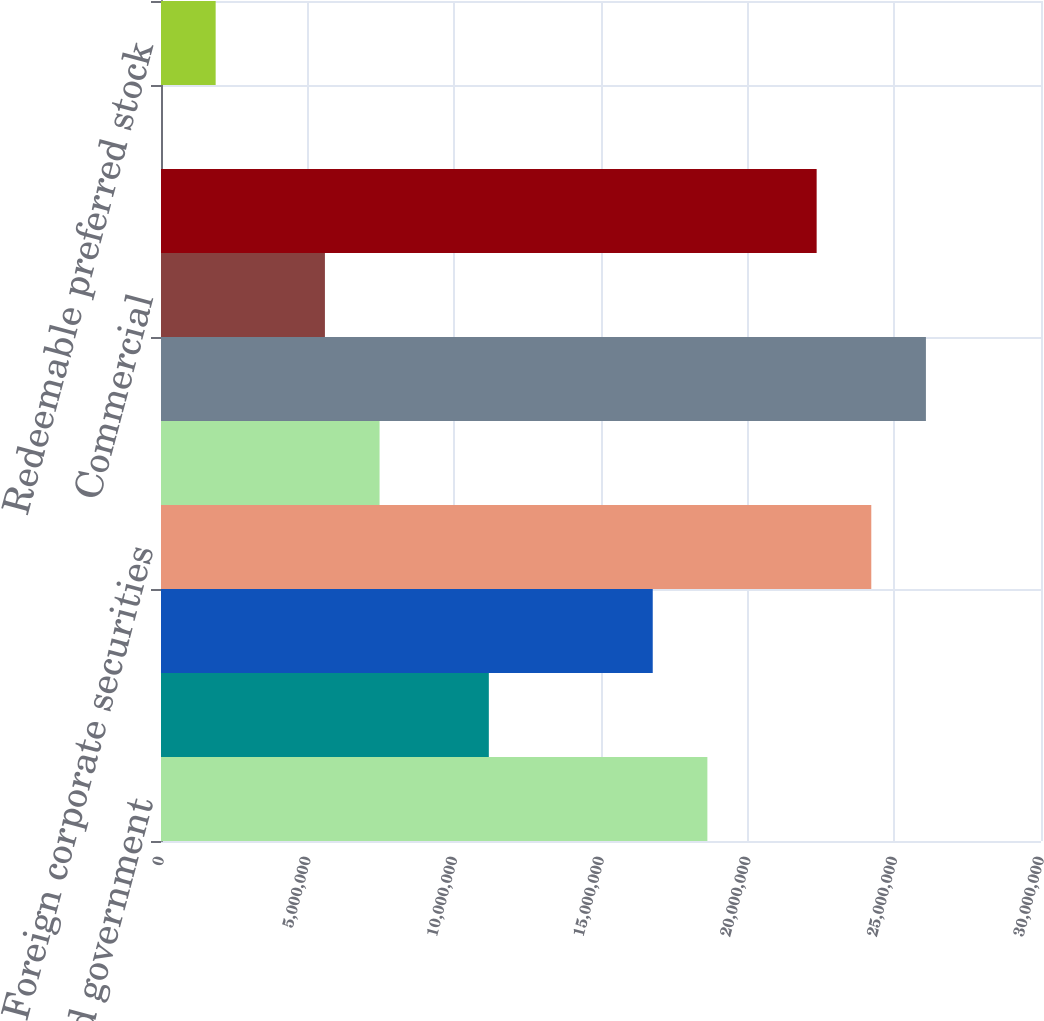<chart> <loc_0><loc_0><loc_500><loc_500><bar_chart><fcel>US government and government<fcel>State municipalities and<fcel>Foreign government securities<fcel>Foreign corporate securities<fcel>Public utilities<fcel>All other corporate bonds<fcel>Commercial<fcel>Agency residential<fcel>Non-agency residential<fcel>Redeemable preferred stock<nl><fcel>1.86265e+07<fcel>1.11761e+07<fcel>1.67639e+07<fcel>2.42143e+07<fcel>7.45091e+06<fcel>2.6077e+07<fcel>5.58831e+06<fcel>2.23517e+07<fcel>494<fcel>1.8631e+06<nl></chart> 